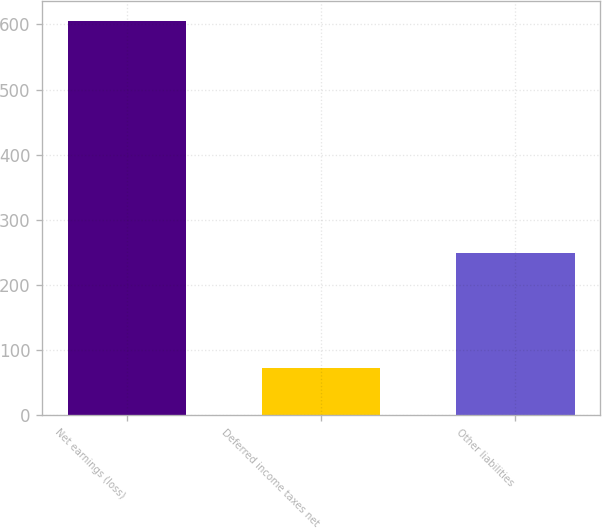<chart> <loc_0><loc_0><loc_500><loc_500><bar_chart><fcel>Net earnings (loss)<fcel>Deferred income taxes net<fcel>Other liabilities<nl><fcel>605<fcel>73<fcel>249<nl></chart> 